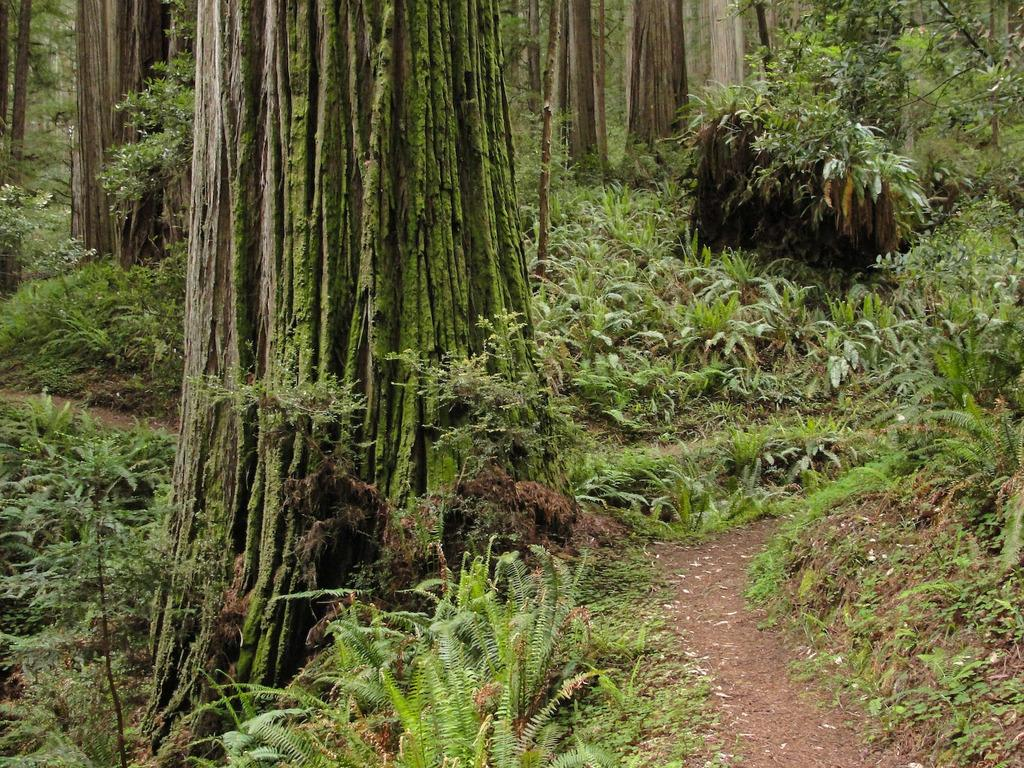What type of vegetation can be seen in the image? There are trees and plants in the image. What is the primary surface visible in the image? There is ground visible at the bottom of the image. What type of wax can be seen melting on the lead in the image? There is no wax or lead present in the image; it features trees, plants, and ground. 